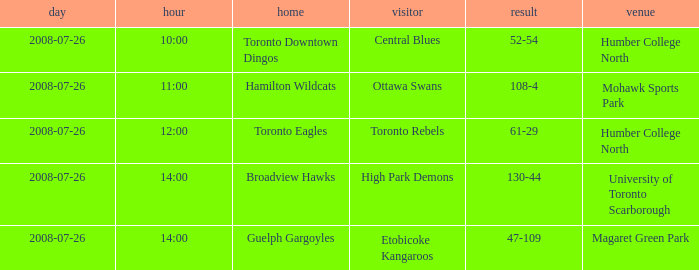When did the High Park Demons play Away? 2008-07-26. Can you parse all the data within this table? {'header': ['day', 'hour', 'home', 'visitor', 'result', 'venue'], 'rows': [['2008-07-26', '10:00', 'Toronto Downtown Dingos', 'Central Blues', '52-54', 'Humber College North'], ['2008-07-26', '11:00', 'Hamilton Wildcats', 'Ottawa Swans', '108-4', 'Mohawk Sports Park'], ['2008-07-26', '12:00', 'Toronto Eagles', 'Toronto Rebels', '61-29', 'Humber College North'], ['2008-07-26', '14:00', 'Broadview Hawks', 'High Park Demons', '130-44', 'University of Toronto Scarborough'], ['2008-07-26', '14:00', 'Guelph Gargoyles', 'Etobicoke Kangaroos', '47-109', 'Magaret Green Park']]} 